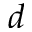<formula> <loc_0><loc_0><loc_500><loc_500>d</formula> 